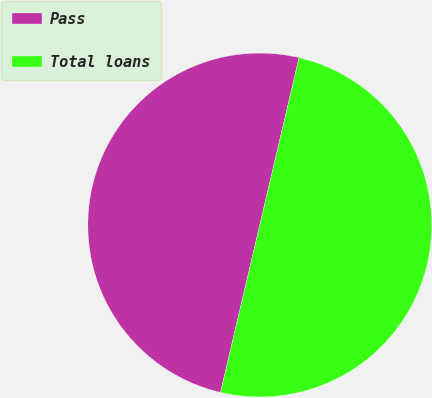Convert chart. <chart><loc_0><loc_0><loc_500><loc_500><pie_chart><fcel>Pass<fcel>Total loans<nl><fcel>50.0%<fcel>50.0%<nl></chart> 